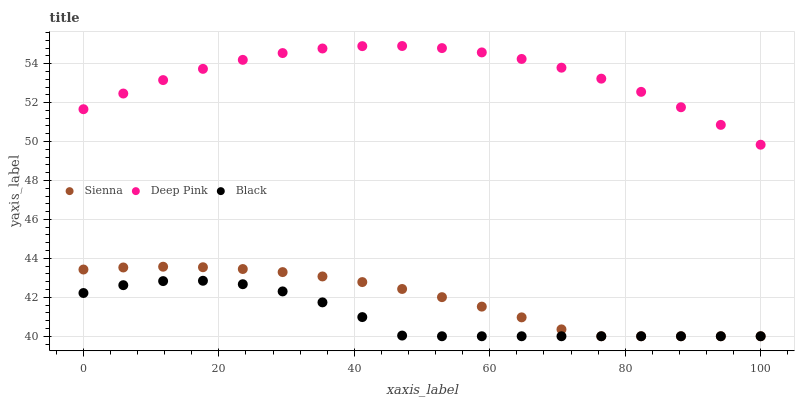Does Black have the minimum area under the curve?
Answer yes or no. Yes. Does Deep Pink have the maximum area under the curve?
Answer yes or no. Yes. Does Deep Pink have the minimum area under the curve?
Answer yes or no. No. Does Black have the maximum area under the curve?
Answer yes or no. No. Is Sienna the smoothest?
Answer yes or no. Yes. Is Black the roughest?
Answer yes or no. Yes. Is Deep Pink the smoothest?
Answer yes or no. No. Is Deep Pink the roughest?
Answer yes or no. No. Does Sienna have the lowest value?
Answer yes or no. Yes. Does Deep Pink have the lowest value?
Answer yes or no. No. Does Deep Pink have the highest value?
Answer yes or no. Yes. Does Black have the highest value?
Answer yes or no. No. Is Black less than Deep Pink?
Answer yes or no. Yes. Is Deep Pink greater than Black?
Answer yes or no. Yes. Does Sienna intersect Black?
Answer yes or no. Yes. Is Sienna less than Black?
Answer yes or no. No. Is Sienna greater than Black?
Answer yes or no. No. Does Black intersect Deep Pink?
Answer yes or no. No. 